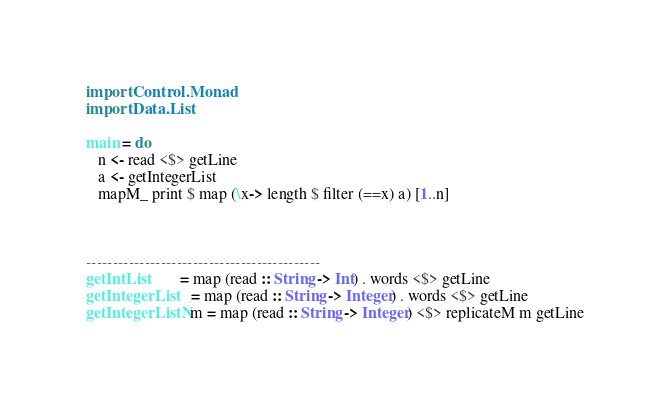Convert code to text. <code><loc_0><loc_0><loc_500><loc_500><_Haskell_>import Control.Monad
import Data.List

main = do
   n <- read <$> getLine
   a <- getIntegerList
   mapM_ print $ map (\x-> length $ filter (==x) a) [1..n]



--------------------------------------------
getIntList        = map (read :: String -> Int) . words <$> getLine
getIntegerList    = map (read :: String -> Integer) . words <$> getLine
getIntegerListN m = map (read :: String -> Integer) <$> replicateM m getLine
</code> 